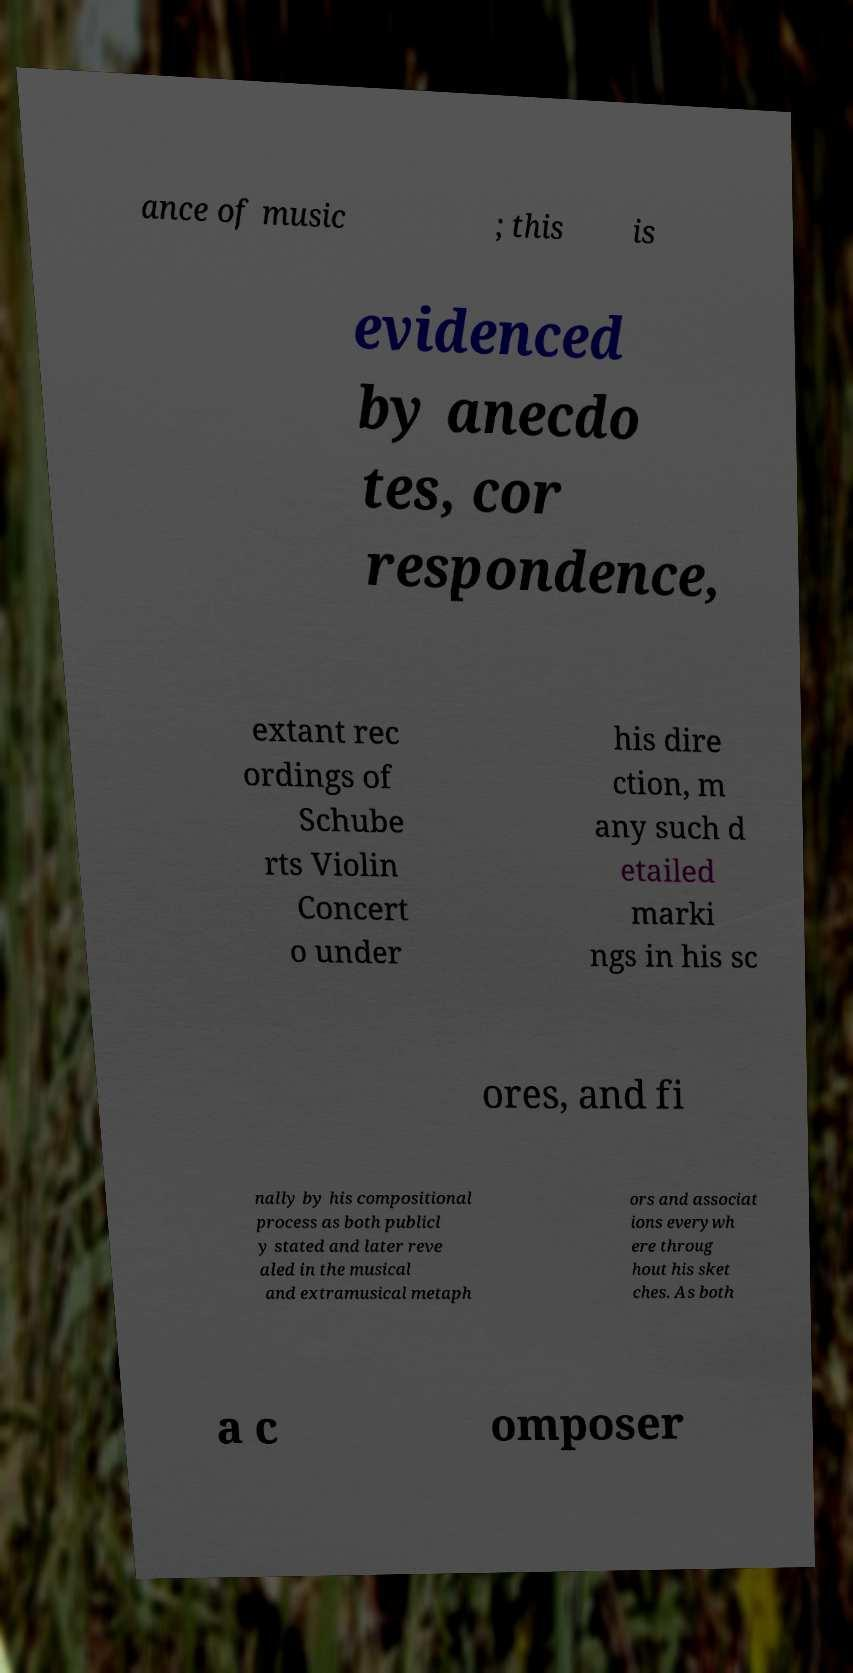There's text embedded in this image that I need extracted. Can you transcribe it verbatim? ance of music ; this is evidenced by anecdo tes, cor respondence, extant rec ordings of Schube rts Violin Concert o under his dire ction, m any such d etailed marki ngs in his sc ores, and fi nally by his compositional process as both publicl y stated and later reve aled in the musical and extramusical metaph ors and associat ions everywh ere throug hout his sket ches. As both a c omposer 